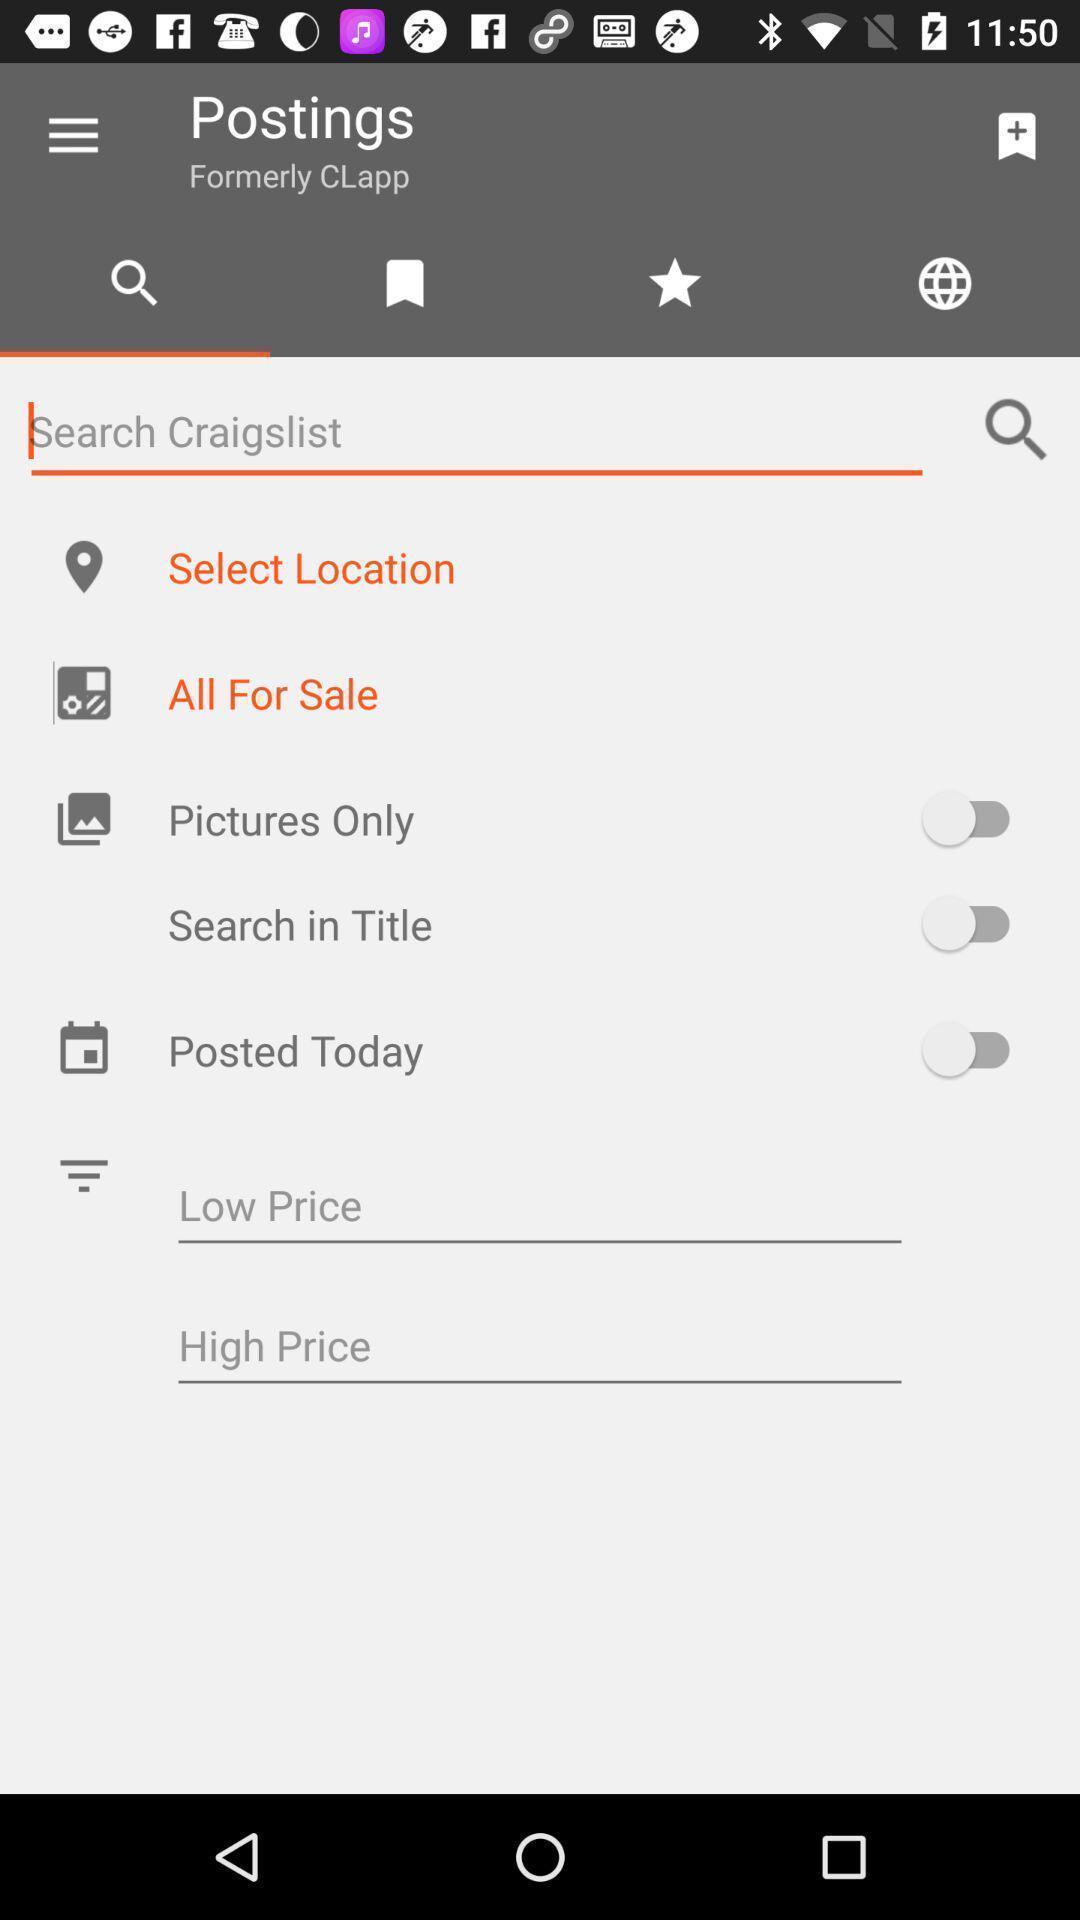Provide a detailed account of this screenshot. Page showing the potions for post. 